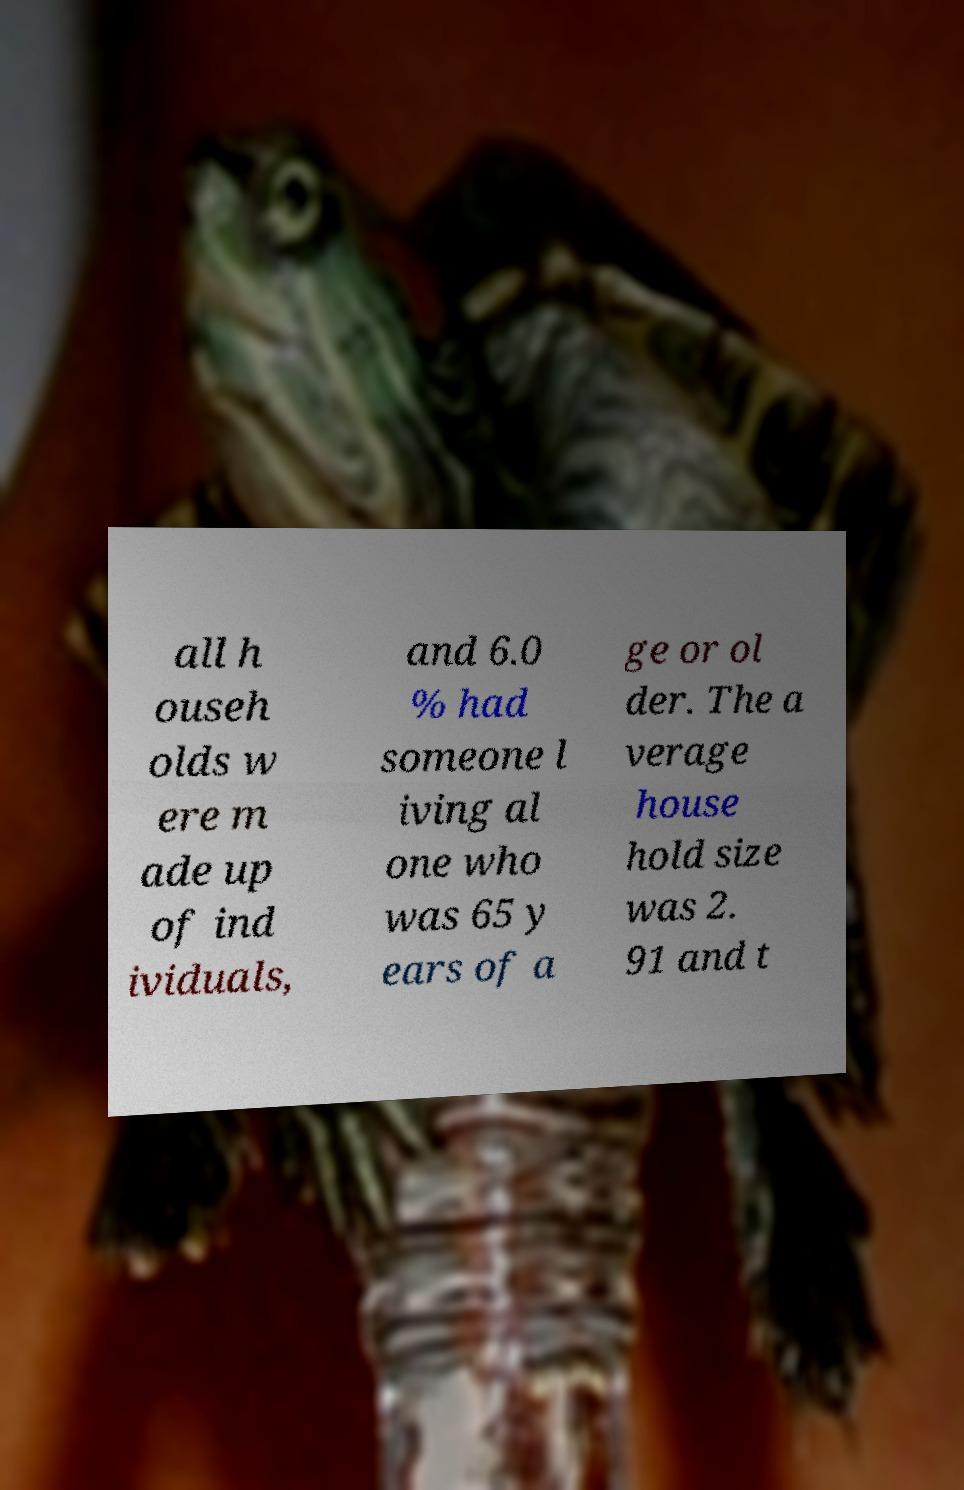There's text embedded in this image that I need extracted. Can you transcribe it verbatim? all h ouseh olds w ere m ade up of ind ividuals, and 6.0 % had someone l iving al one who was 65 y ears of a ge or ol der. The a verage house hold size was 2. 91 and t 